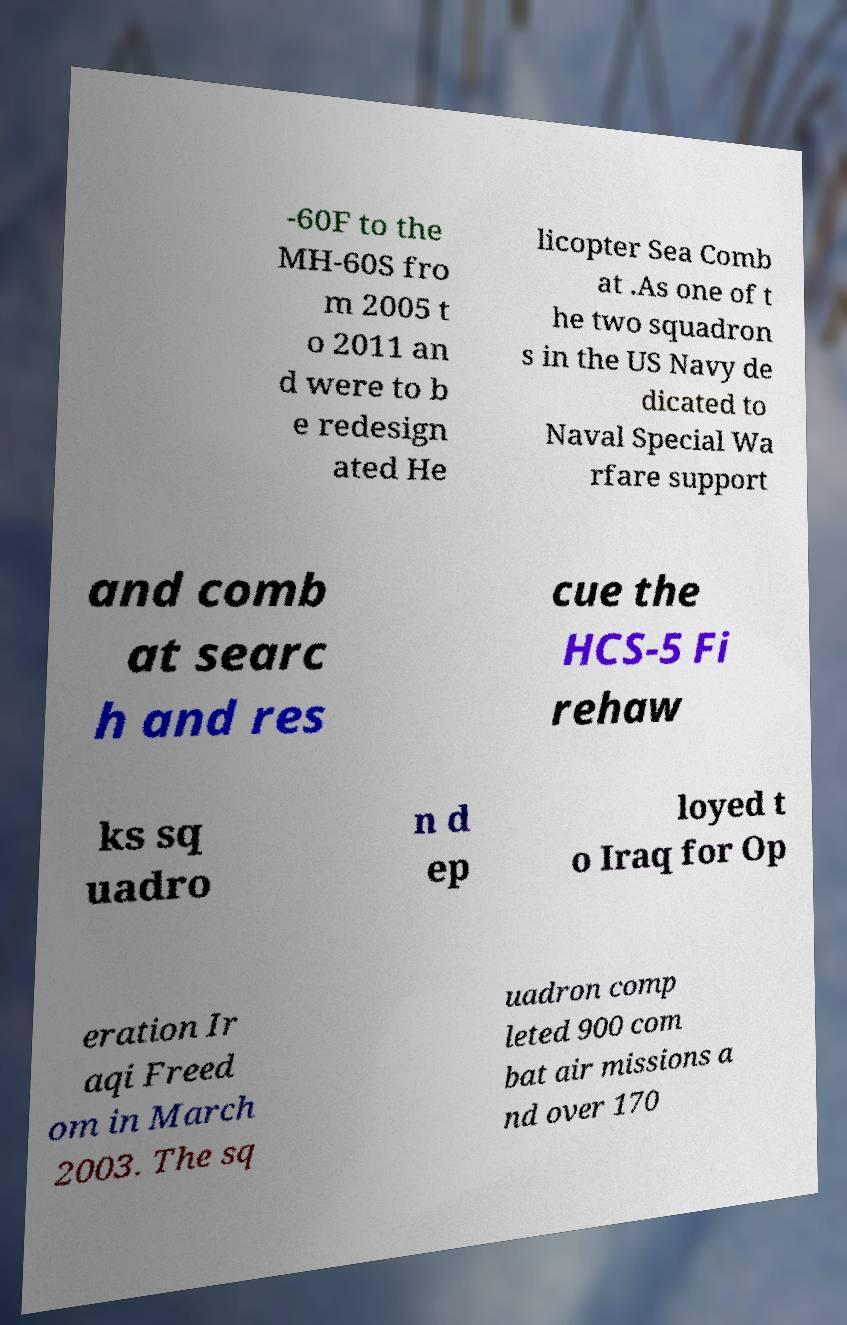There's text embedded in this image that I need extracted. Can you transcribe it verbatim? -60F to the MH-60S fro m 2005 t o 2011 an d were to b e redesign ated He licopter Sea Comb at .As one of t he two squadron s in the US Navy de dicated to Naval Special Wa rfare support and comb at searc h and res cue the HCS-5 Fi rehaw ks sq uadro n d ep loyed t o Iraq for Op eration Ir aqi Freed om in March 2003. The sq uadron comp leted 900 com bat air missions a nd over 170 